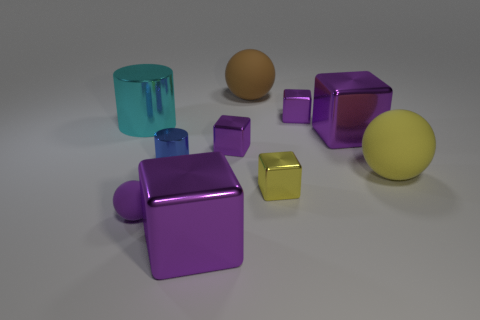Is the shape of the large purple thing that is in front of the small yellow object the same as the large purple metal object behind the large yellow rubber ball?
Give a very brief answer. Yes. What material is the big cyan object that is the same shape as the small blue object?
Keep it short and to the point. Metal. What color is the object that is behind the cyan metal cylinder and in front of the brown rubber object?
Keep it short and to the point. Purple. There is a big rubber object that is in front of the sphere that is behind the tiny cylinder; are there any tiny purple rubber objects on the right side of it?
Keep it short and to the point. No. How many things are large gray matte spheres or large yellow things?
Offer a very short reply. 1. Does the tiny yellow thing have the same material as the purple thing behind the cyan shiny object?
Offer a terse response. Yes. Is there any other thing of the same color as the small rubber ball?
Provide a short and direct response. Yes. How many things are purple shiny cubes behind the blue object or cyan shiny cylinders that are left of the big brown rubber ball?
Make the answer very short. 4. What is the shape of the big metal thing that is both on the right side of the cyan metal cylinder and behind the blue metal cylinder?
Your answer should be compact. Cube. What number of small purple matte spheres are on the left side of the big cyan object that is to the left of the small yellow thing?
Your answer should be compact. 0. 